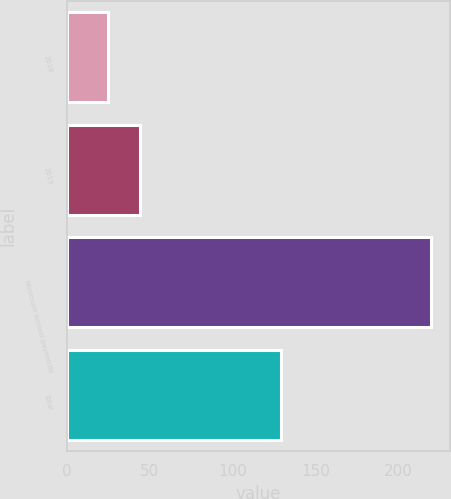<chart> <loc_0><loc_0><loc_500><loc_500><bar_chart><fcel>2018<fcel>2019<fcel>Minimum annual payments<fcel>Total<nl><fcel>25<fcel>44.5<fcel>220<fcel>129<nl></chart> 